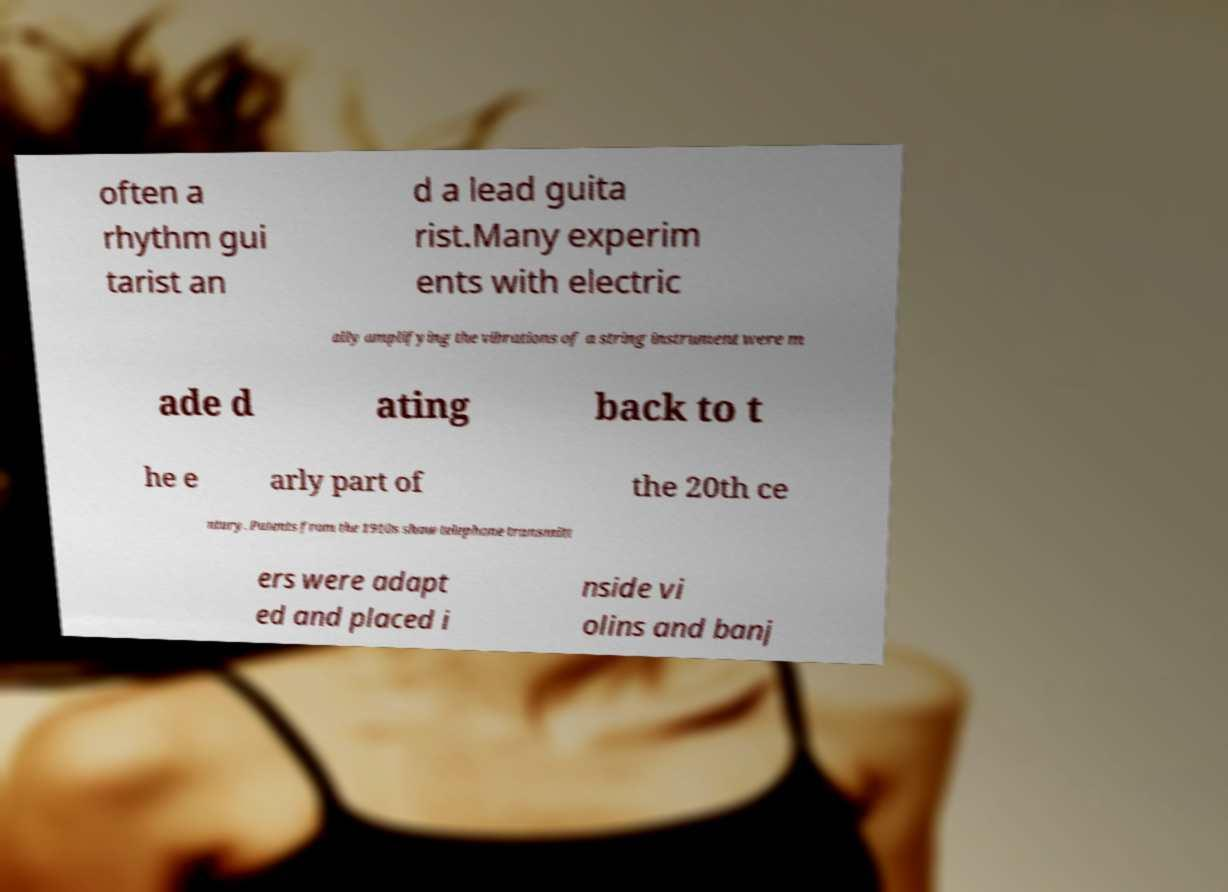I need the written content from this picture converted into text. Can you do that? often a rhythm gui tarist an d a lead guita rist.Many experim ents with electric ally amplifying the vibrations of a string instrument were m ade d ating back to t he e arly part of the 20th ce ntury. Patents from the 1910s show telephone transmitt ers were adapt ed and placed i nside vi olins and banj 